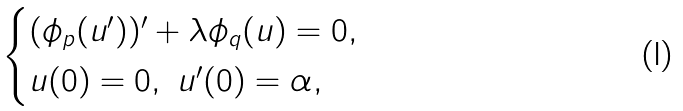<formula> <loc_0><loc_0><loc_500><loc_500>\begin{cases} ( \phi _ { p } ( u ^ { \prime } ) ) ^ { \prime } + \lambda \phi _ { q } ( u ) = 0 , \\ u ( 0 ) = 0 , \ u ^ { \prime } ( 0 ) = \alpha , \end{cases}</formula> 